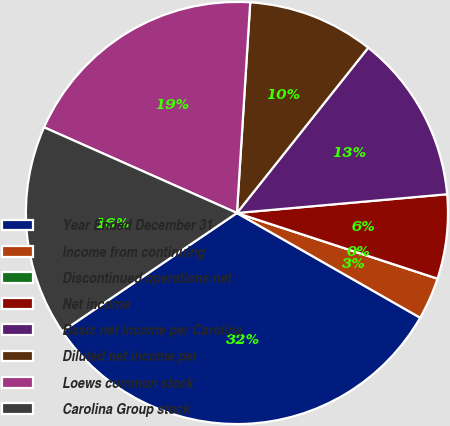Convert chart. <chart><loc_0><loc_0><loc_500><loc_500><pie_chart><fcel>Year Ended December 31<fcel>Income from continuing<fcel>Discontinued operations net<fcel>Net income<fcel>Basic net income per Carolina<fcel>Diluted net income per<fcel>Loews common stock<fcel>Carolina Group stock<nl><fcel>32.26%<fcel>3.23%<fcel>0.0%<fcel>6.45%<fcel>12.9%<fcel>9.68%<fcel>19.35%<fcel>16.13%<nl></chart> 